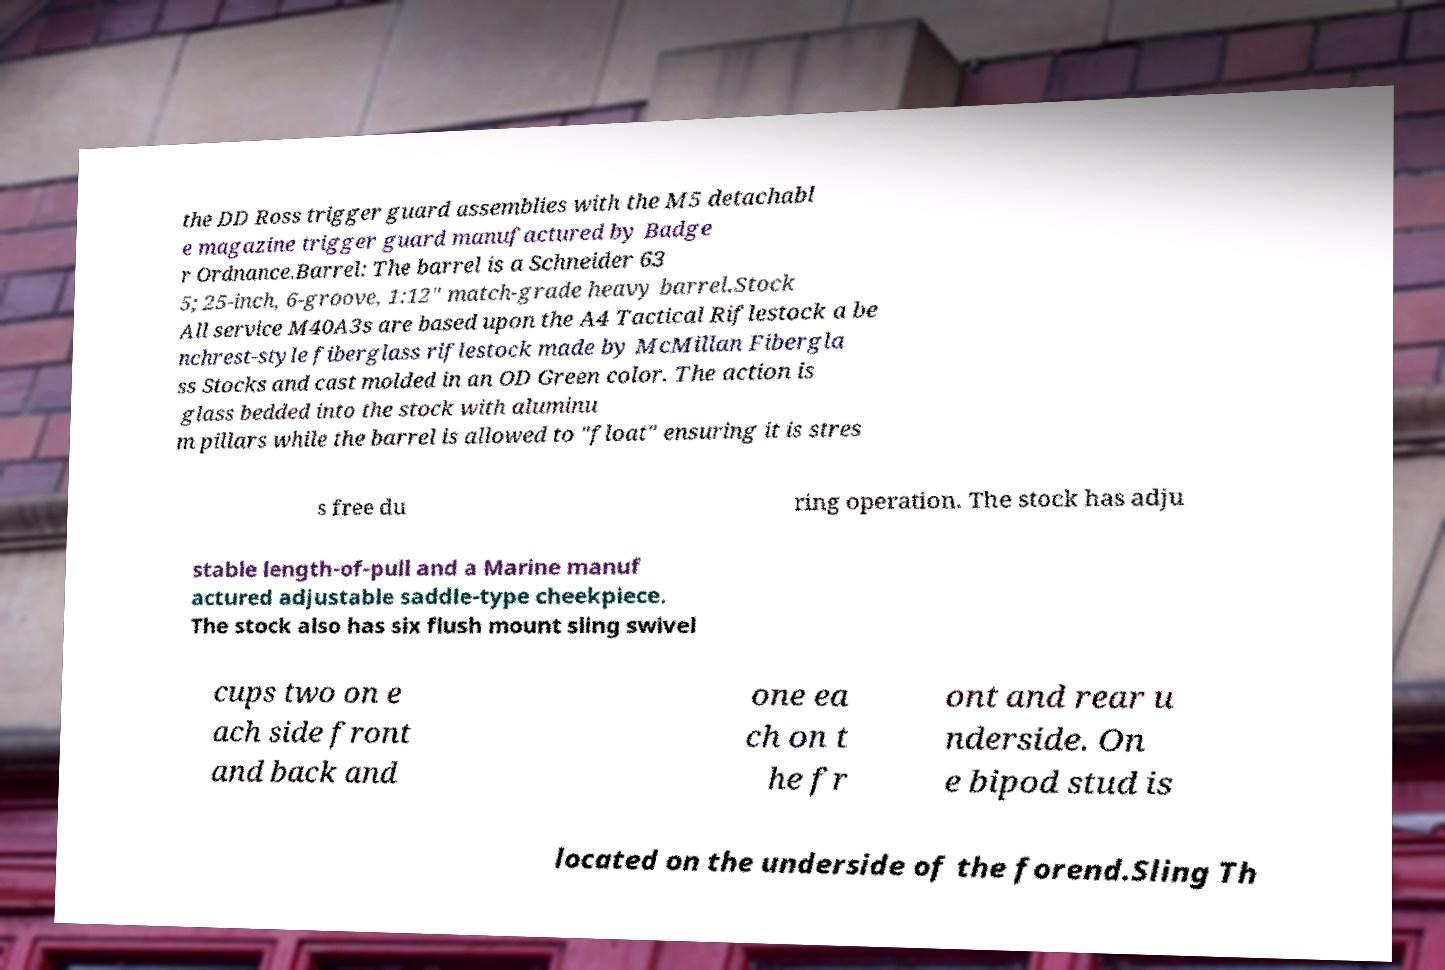I need the written content from this picture converted into text. Can you do that? the DD Ross trigger guard assemblies with the M5 detachabl e magazine trigger guard manufactured by Badge r Ordnance.Barrel: The barrel is a Schneider 63 5; 25-inch, 6-groove, 1:12" match-grade heavy barrel.Stock All service M40A3s are based upon the A4 Tactical Riflestock a be nchrest-style fiberglass riflestock made by McMillan Fibergla ss Stocks and cast molded in an OD Green color. The action is glass bedded into the stock with aluminu m pillars while the barrel is allowed to "float" ensuring it is stres s free du ring operation. The stock has adju stable length-of-pull and a Marine manuf actured adjustable saddle-type cheekpiece. The stock also has six flush mount sling swivel cups two on e ach side front and back and one ea ch on t he fr ont and rear u nderside. On e bipod stud is located on the underside of the forend.Sling Th 